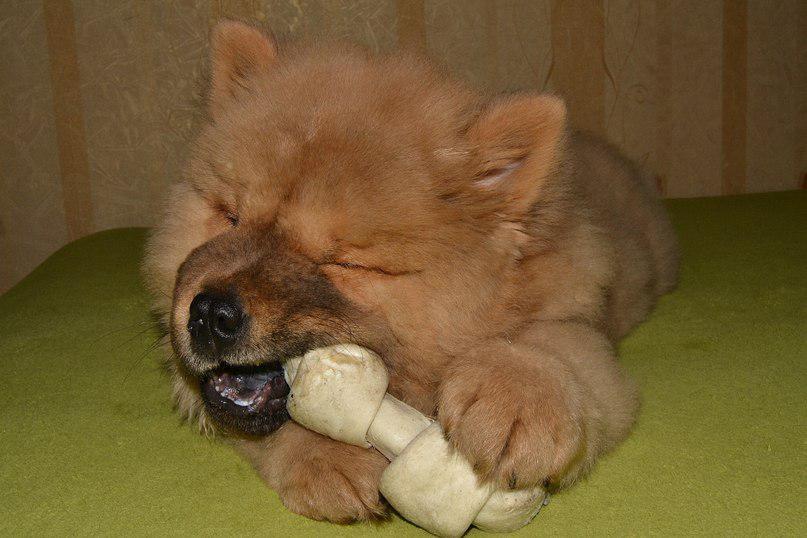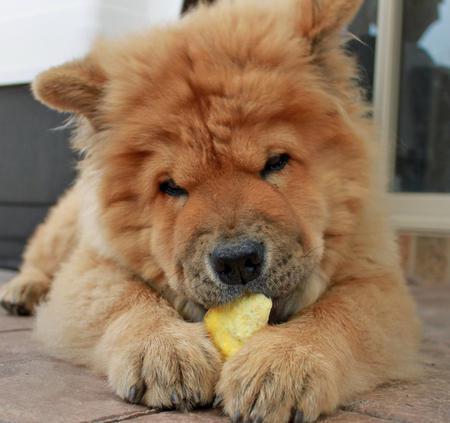The first image is the image on the left, the second image is the image on the right. Assess this claim about the two images: "One image features a chow standing on a red brick-colored surface and looking upward.". Correct or not? Answer yes or no. No. The first image is the image on the left, the second image is the image on the right. Analyze the images presented: Is the assertion "A single dog is lying down in the image on the right." valid? Answer yes or no. Yes. 